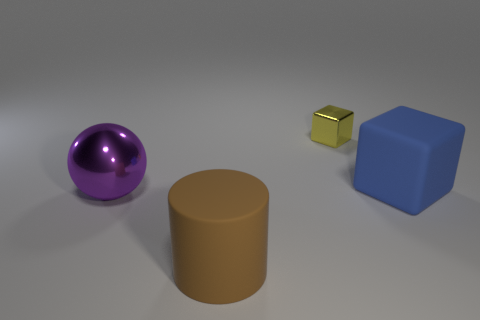Add 2 big green shiny spheres. How many objects exist? 6 Subtract all spheres. How many objects are left? 3 Subtract all big purple metal balls. Subtract all cylinders. How many objects are left? 2 Add 2 blue things. How many blue things are left? 3 Add 4 large metallic spheres. How many large metallic spheres exist? 5 Subtract 0 red blocks. How many objects are left? 4 